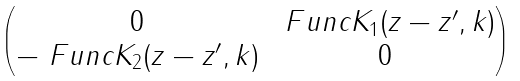Convert formula to latex. <formula><loc_0><loc_0><loc_500><loc_500>\begin{pmatrix} 0 & \ F u n c { K } _ { 1 } ( z - z ^ { \prime } , k ) \\ - \ F u n c { K } _ { 2 } ( z - z ^ { \prime } , k ) & 0 \end{pmatrix}</formula> 